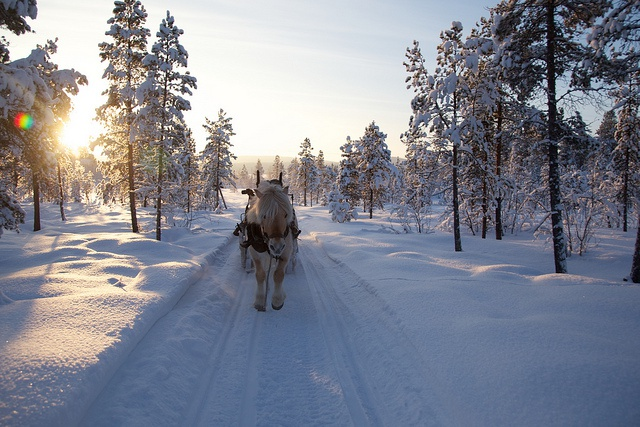Describe the objects in this image and their specific colors. I can see a horse in gray and black tones in this image. 